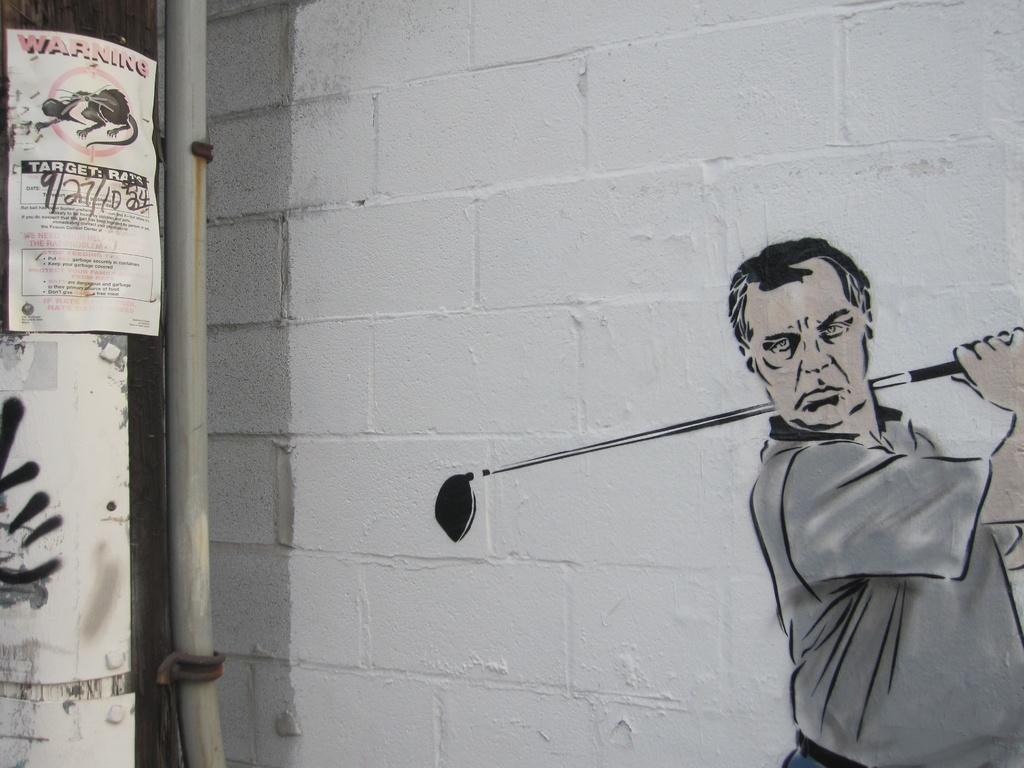What is on the wall in the image? There is graffiti and a poster on the wall in the image. What else can be seen on the left side of the image? There is a pipe on the left side of the image. How many toes can be seen on the chickens in the image? There are no chickens present in the image, so it is not possible to determine the number of toes. What type of store is visible in the image? There is no store visible in the image; it features graffiti, a pipe, and a poster on a wall. 